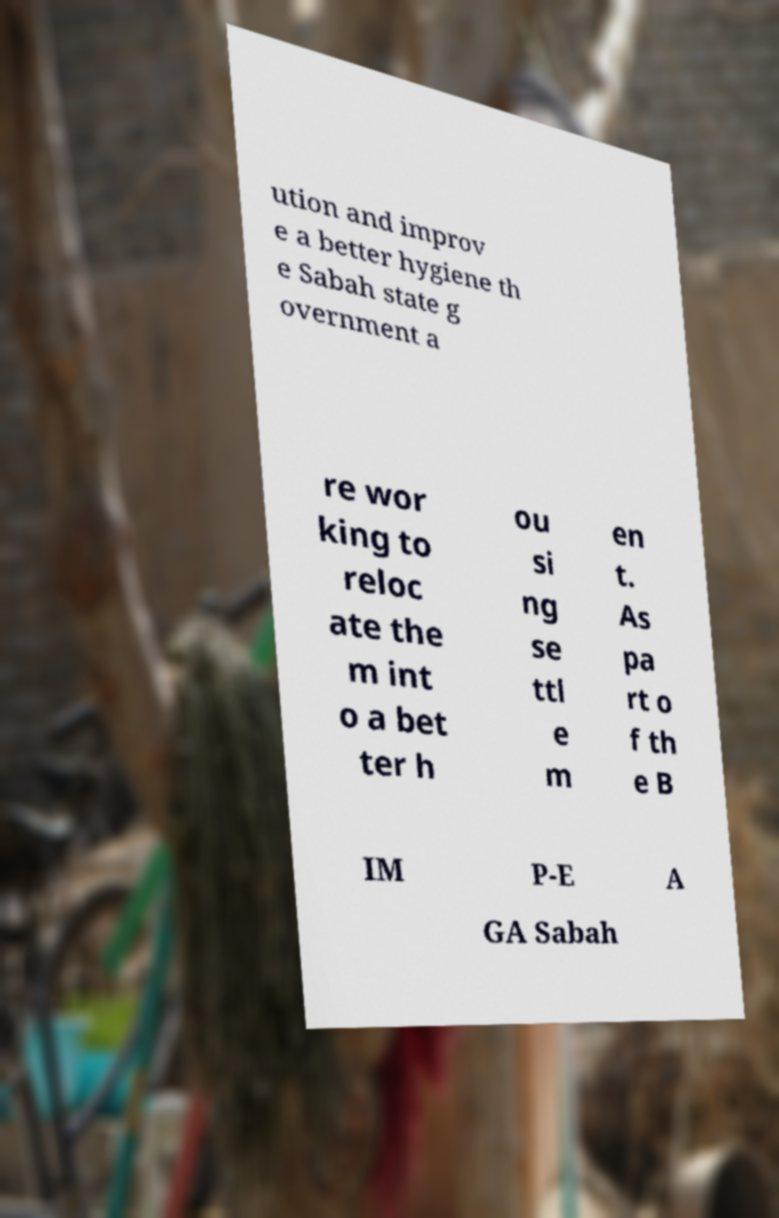Please identify and transcribe the text found in this image. ution and improv e a better hygiene th e Sabah state g overnment a re wor king to reloc ate the m int o a bet ter h ou si ng se ttl e m en t. As pa rt o f th e B IM P-E A GA Sabah 